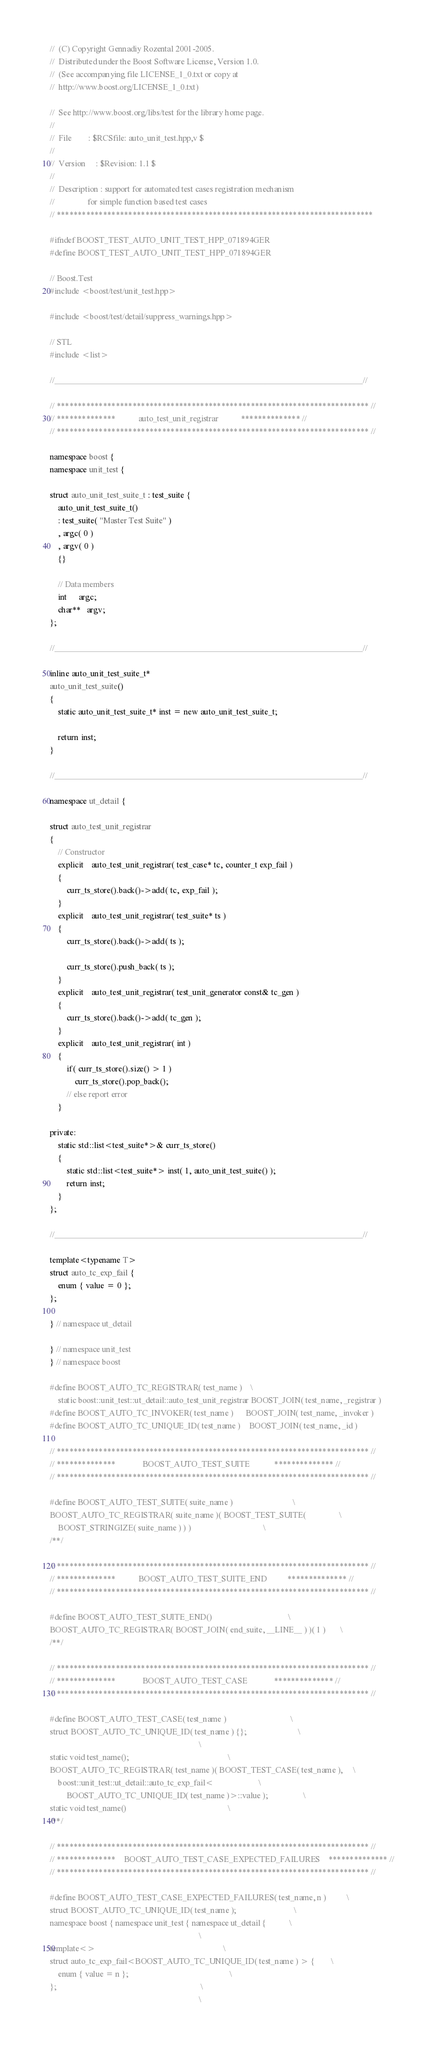<code> <loc_0><loc_0><loc_500><loc_500><_C++_>//  (C) Copyright Gennadiy Rozental 2001-2005.
//  Distributed under the Boost Software License, Version 1.0.
//  (See accompanying file LICENSE_1_0.txt or copy at 
//  http://www.boost.org/LICENSE_1_0.txt)

//  See http://www.boost.org/libs/test for the library home page.
//
//  File        : $RCSfile: auto_unit_test.hpp,v $
//
//  Version     : $Revision: 1.1 $
//
//  Description : support for automated test cases registration mechanism
//                for simple function based test cases
// ***************************************************************************

#ifndef BOOST_TEST_AUTO_UNIT_TEST_HPP_071894GER
#define BOOST_TEST_AUTO_UNIT_TEST_HPP_071894GER

// Boost.Test
#include <boost/test/unit_test.hpp>

#include <boost/test/detail/suppress_warnings.hpp>

// STL
#include <list>

//____________________________________________________________________________//

// ************************************************************************** //
// **************           auto_test_unit_registrar           ************** //
// ************************************************************************** //

namespace boost {
namespace unit_test {

struct auto_unit_test_suite_t : test_suite {
    auto_unit_test_suite_t() 
    : test_suite( "Master Test Suite" )
    , argc( 0 )
    , argv( 0 )
    {}
    
    // Data members    
    int      argc;
    char**   argv;
};

//____________________________________________________________________________//

inline auto_unit_test_suite_t*
auto_unit_test_suite()
{
    static auto_unit_test_suite_t* inst = new auto_unit_test_suite_t;

    return inst;
}

//____________________________________________________________________________//

namespace ut_detail {

struct auto_test_unit_registrar
{
    // Constructor
    explicit    auto_test_unit_registrar( test_case* tc, counter_t exp_fail )
    {
        curr_ts_store().back()->add( tc, exp_fail );
    }
    explicit    auto_test_unit_registrar( test_suite* ts )
    {
        curr_ts_store().back()->add( ts );

        curr_ts_store().push_back( ts );
    }
    explicit    auto_test_unit_registrar( test_unit_generator const& tc_gen )
    {
        curr_ts_store().back()->add( tc_gen );
    }
    explicit    auto_test_unit_registrar( int )
    {
        if( curr_ts_store().size() > 1 )
            curr_ts_store().pop_back();
        // else report error
    }

private:
    static std::list<test_suite*>& curr_ts_store()
    {
        static std::list<test_suite*> inst( 1, auto_unit_test_suite() );
        return inst;
    }
};

//____________________________________________________________________________//

template<typename T>
struct auto_tc_exp_fail {
    enum { value = 0 };
};

} // namespace ut_detail

} // namespace unit_test
} // namespace boost

#define BOOST_AUTO_TC_REGISTRAR( test_name )    \
    static boost::unit_test::ut_detail::auto_test_unit_registrar BOOST_JOIN( test_name, _registrar )
#define BOOST_AUTO_TC_INVOKER( test_name )      BOOST_JOIN( test_name, _invoker )
#define BOOST_AUTO_TC_UNIQUE_ID( test_name )    BOOST_JOIN( test_name, _id )

// ************************************************************************** //
// **************             BOOST_AUTO_TEST_SUITE            ************** //
// ************************************************************************** //

#define BOOST_AUTO_TEST_SUITE( suite_name )                             \
BOOST_AUTO_TC_REGISTRAR( suite_name )( BOOST_TEST_SUITE(                \
    BOOST_STRINGIZE( suite_name ) ) )                                   \
/**/

// ************************************************************************** //
// **************           BOOST_AUTO_TEST_SUITE_END          ************** //
// ************************************************************************** //

#define BOOST_AUTO_TEST_SUITE_END()                                     \
BOOST_AUTO_TC_REGISTRAR( BOOST_JOIN( end_suite, __LINE__ ) )( 1 )       \
/**/

// ************************************************************************** //
// **************             BOOST_AUTO_TEST_CASE             ************** //
// ************************************************************************** //

#define BOOST_AUTO_TEST_CASE( test_name )                               \
struct BOOST_AUTO_TC_UNIQUE_ID( test_name ) {};                         \
                                                                        \
static void test_name();                                                \
BOOST_AUTO_TC_REGISTRAR( test_name )( BOOST_TEST_CASE( test_name ),     \
    boost::unit_test::ut_detail::auto_tc_exp_fail<                      \
        BOOST_AUTO_TC_UNIQUE_ID( test_name )>::value );                 \
static void test_name()                                                 \
/**/

// ************************************************************************** //
// **************    BOOST_AUTO_TEST_CASE_EXPECTED_FAILURES    ************** //
// ************************************************************************** //

#define BOOST_AUTO_TEST_CASE_EXPECTED_FAILURES( test_name, n )          \
struct BOOST_AUTO_TC_UNIQUE_ID( test_name );                            \
namespace boost { namespace unit_test { namespace ut_detail {           \
                                                                        \
template<>                                                              \
struct auto_tc_exp_fail<BOOST_AUTO_TC_UNIQUE_ID( test_name ) > {        \
    enum { value = n };                                                 \
};                                                                      \
                                                                        \</code> 